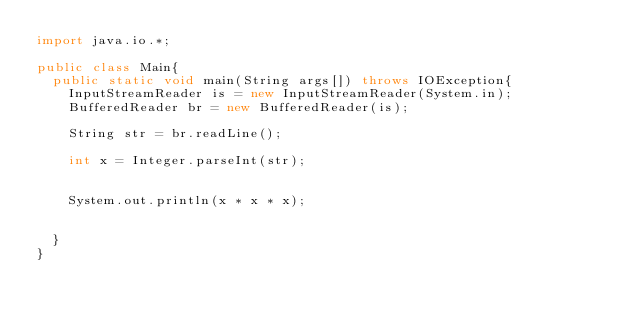Convert code to text. <code><loc_0><loc_0><loc_500><loc_500><_Java_>import java.io.*;

public class Main{
	public static void main(String args[]) throws IOException{
		InputStreamReader is = new InputStreamReader(System.in);
		BufferedReader br = new BufferedReader(is);

		String str = br.readLine();

		int x = Integer.parseInt(str);


		System.out.println(x * x * x);

		
	}
}</code> 